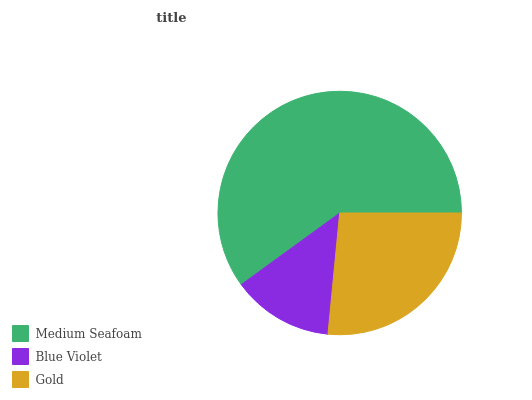Is Blue Violet the minimum?
Answer yes or no. Yes. Is Medium Seafoam the maximum?
Answer yes or no. Yes. Is Gold the minimum?
Answer yes or no. No. Is Gold the maximum?
Answer yes or no. No. Is Gold greater than Blue Violet?
Answer yes or no. Yes. Is Blue Violet less than Gold?
Answer yes or no. Yes. Is Blue Violet greater than Gold?
Answer yes or no. No. Is Gold less than Blue Violet?
Answer yes or no. No. Is Gold the high median?
Answer yes or no. Yes. Is Gold the low median?
Answer yes or no. Yes. Is Medium Seafoam the high median?
Answer yes or no. No. Is Medium Seafoam the low median?
Answer yes or no. No. 